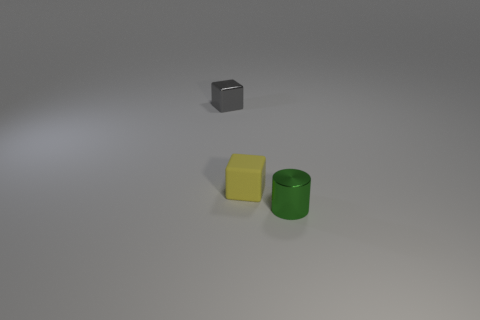Is the color of the object right of the yellow cube the same as the small block that is behind the yellow matte block?
Make the answer very short. No. There is a metallic thing in front of the yellow cube that is in front of the tiny thing that is left of the tiny rubber block; what shape is it?
Make the answer very short. Cylinder. The small object that is both to the left of the small metal cylinder and right of the gray object has what shape?
Offer a very short reply. Cube. How many tiny things are on the left side of the tiny shiny thing that is to the right of the small metal thing that is behind the cylinder?
Provide a succinct answer. 2. The rubber object that is the same shape as the gray metal thing is what size?
Make the answer very short. Small. Is there any other thing that is the same size as the green object?
Give a very brief answer. Yes. Do the cube to the left of the yellow matte cube and the cylinder have the same material?
Offer a terse response. Yes. There is a tiny shiny object that is the same shape as the tiny matte object; what is its color?
Offer a very short reply. Gray. There is a tiny metallic thing that is to the left of the tiny cylinder; is its shape the same as the tiny object that is right of the matte object?
Offer a very short reply. No. How many cylinders are cyan rubber objects or tiny objects?
Your answer should be compact. 1. 